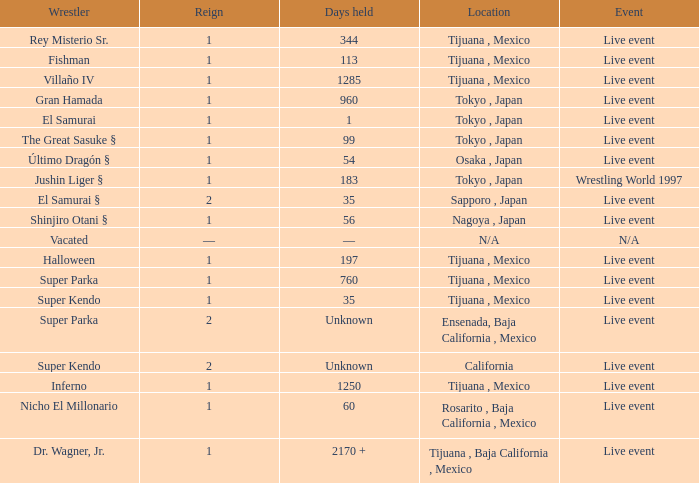What is the reign for super kendo who held it for 35 days? 1.0. 